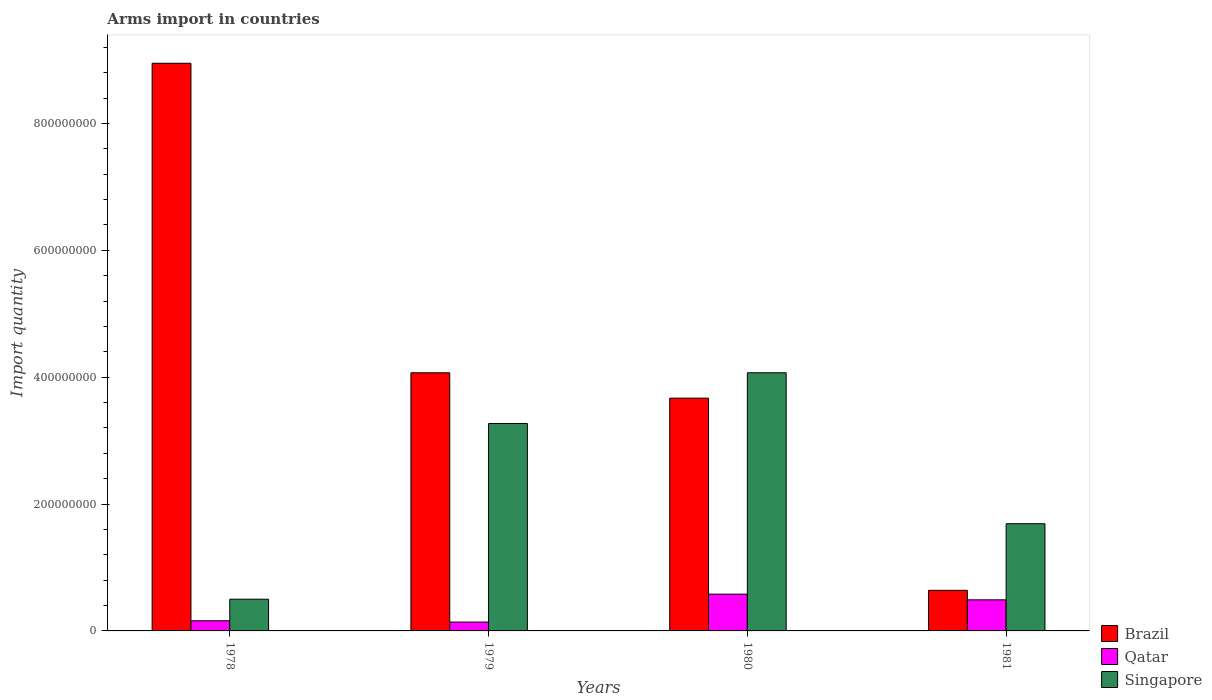How many different coloured bars are there?
Provide a short and direct response. 3. How many bars are there on the 1st tick from the left?
Provide a short and direct response. 3. How many bars are there on the 4th tick from the right?
Provide a short and direct response. 3. What is the label of the 2nd group of bars from the left?
Make the answer very short. 1979. In how many cases, is the number of bars for a given year not equal to the number of legend labels?
Give a very brief answer. 0. What is the total arms import in Qatar in 1978?
Make the answer very short. 1.60e+07. Across all years, what is the maximum total arms import in Singapore?
Provide a short and direct response. 4.07e+08. Across all years, what is the minimum total arms import in Brazil?
Keep it short and to the point. 6.40e+07. In which year was the total arms import in Singapore maximum?
Make the answer very short. 1980. In which year was the total arms import in Brazil minimum?
Offer a very short reply. 1981. What is the total total arms import in Qatar in the graph?
Provide a short and direct response. 1.37e+08. What is the difference between the total arms import in Brazil in 1978 and that in 1980?
Ensure brevity in your answer.  5.28e+08. What is the difference between the total arms import in Qatar in 1978 and the total arms import in Brazil in 1980?
Provide a succinct answer. -3.51e+08. What is the average total arms import in Singapore per year?
Provide a short and direct response. 2.38e+08. In the year 1979, what is the difference between the total arms import in Qatar and total arms import in Singapore?
Your response must be concise. -3.13e+08. What is the ratio of the total arms import in Brazil in 1978 to that in 1981?
Your answer should be very brief. 13.98. Is the total arms import in Qatar in 1978 less than that in 1980?
Offer a terse response. Yes. What is the difference between the highest and the second highest total arms import in Brazil?
Your answer should be compact. 4.88e+08. What is the difference between the highest and the lowest total arms import in Brazil?
Your answer should be very brief. 8.31e+08. What does the 3rd bar from the left in 1978 represents?
Provide a short and direct response. Singapore. What does the 3rd bar from the right in 1980 represents?
Ensure brevity in your answer.  Brazil. Is it the case that in every year, the sum of the total arms import in Brazil and total arms import in Qatar is greater than the total arms import in Singapore?
Keep it short and to the point. No. Are all the bars in the graph horizontal?
Give a very brief answer. No. What is the difference between two consecutive major ticks on the Y-axis?
Offer a very short reply. 2.00e+08. Does the graph contain any zero values?
Your answer should be compact. No. Does the graph contain grids?
Your response must be concise. No. Where does the legend appear in the graph?
Provide a succinct answer. Bottom right. What is the title of the graph?
Make the answer very short. Arms import in countries. What is the label or title of the X-axis?
Your answer should be compact. Years. What is the label or title of the Y-axis?
Provide a succinct answer. Import quantity. What is the Import quantity in Brazil in 1978?
Offer a terse response. 8.95e+08. What is the Import quantity of Qatar in 1978?
Offer a very short reply. 1.60e+07. What is the Import quantity in Singapore in 1978?
Provide a succinct answer. 5.00e+07. What is the Import quantity in Brazil in 1979?
Ensure brevity in your answer.  4.07e+08. What is the Import quantity in Qatar in 1979?
Make the answer very short. 1.40e+07. What is the Import quantity of Singapore in 1979?
Your answer should be very brief. 3.27e+08. What is the Import quantity in Brazil in 1980?
Offer a terse response. 3.67e+08. What is the Import quantity of Qatar in 1980?
Offer a terse response. 5.80e+07. What is the Import quantity of Singapore in 1980?
Ensure brevity in your answer.  4.07e+08. What is the Import quantity in Brazil in 1981?
Your answer should be compact. 6.40e+07. What is the Import quantity in Qatar in 1981?
Your response must be concise. 4.90e+07. What is the Import quantity of Singapore in 1981?
Give a very brief answer. 1.69e+08. Across all years, what is the maximum Import quantity in Brazil?
Ensure brevity in your answer.  8.95e+08. Across all years, what is the maximum Import quantity in Qatar?
Your answer should be very brief. 5.80e+07. Across all years, what is the maximum Import quantity in Singapore?
Provide a succinct answer. 4.07e+08. Across all years, what is the minimum Import quantity of Brazil?
Provide a succinct answer. 6.40e+07. Across all years, what is the minimum Import quantity in Qatar?
Offer a very short reply. 1.40e+07. What is the total Import quantity in Brazil in the graph?
Your answer should be compact. 1.73e+09. What is the total Import quantity in Qatar in the graph?
Your answer should be very brief. 1.37e+08. What is the total Import quantity in Singapore in the graph?
Your response must be concise. 9.53e+08. What is the difference between the Import quantity of Brazil in 1978 and that in 1979?
Your answer should be compact. 4.88e+08. What is the difference between the Import quantity of Singapore in 1978 and that in 1979?
Your answer should be very brief. -2.77e+08. What is the difference between the Import quantity in Brazil in 1978 and that in 1980?
Give a very brief answer. 5.28e+08. What is the difference between the Import quantity of Qatar in 1978 and that in 1980?
Offer a very short reply. -4.20e+07. What is the difference between the Import quantity in Singapore in 1978 and that in 1980?
Make the answer very short. -3.57e+08. What is the difference between the Import quantity of Brazil in 1978 and that in 1981?
Your answer should be compact. 8.31e+08. What is the difference between the Import quantity in Qatar in 1978 and that in 1981?
Offer a very short reply. -3.30e+07. What is the difference between the Import quantity of Singapore in 1978 and that in 1981?
Give a very brief answer. -1.19e+08. What is the difference between the Import quantity in Brazil in 1979 and that in 1980?
Offer a terse response. 4.00e+07. What is the difference between the Import quantity in Qatar in 1979 and that in 1980?
Provide a short and direct response. -4.40e+07. What is the difference between the Import quantity in Singapore in 1979 and that in 1980?
Your answer should be very brief. -8.00e+07. What is the difference between the Import quantity of Brazil in 1979 and that in 1981?
Offer a very short reply. 3.43e+08. What is the difference between the Import quantity of Qatar in 1979 and that in 1981?
Make the answer very short. -3.50e+07. What is the difference between the Import quantity in Singapore in 1979 and that in 1981?
Make the answer very short. 1.58e+08. What is the difference between the Import quantity of Brazil in 1980 and that in 1981?
Your answer should be compact. 3.03e+08. What is the difference between the Import quantity of Qatar in 1980 and that in 1981?
Ensure brevity in your answer.  9.00e+06. What is the difference between the Import quantity in Singapore in 1980 and that in 1981?
Your response must be concise. 2.38e+08. What is the difference between the Import quantity in Brazil in 1978 and the Import quantity in Qatar in 1979?
Your answer should be very brief. 8.81e+08. What is the difference between the Import quantity of Brazil in 1978 and the Import quantity of Singapore in 1979?
Make the answer very short. 5.68e+08. What is the difference between the Import quantity of Qatar in 1978 and the Import quantity of Singapore in 1979?
Ensure brevity in your answer.  -3.11e+08. What is the difference between the Import quantity of Brazil in 1978 and the Import quantity of Qatar in 1980?
Offer a terse response. 8.37e+08. What is the difference between the Import quantity in Brazil in 1978 and the Import quantity in Singapore in 1980?
Your response must be concise. 4.88e+08. What is the difference between the Import quantity in Qatar in 1978 and the Import quantity in Singapore in 1980?
Offer a terse response. -3.91e+08. What is the difference between the Import quantity of Brazil in 1978 and the Import quantity of Qatar in 1981?
Your response must be concise. 8.46e+08. What is the difference between the Import quantity in Brazil in 1978 and the Import quantity in Singapore in 1981?
Keep it short and to the point. 7.26e+08. What is the difference between the Import quantity of Qatar in 1978 and the Import quantity of Singapore in 1981?
Make the answer very short. -1.53e+08. What is the difference between the Import quantity in Brazil in 1979 and the Import quantity in Qatar in 1980?
Provide a succinct answer. 3.49e+08. What is the difference between the Import quantity in Brazil in 1979 and the Import quantity in Singapore in 1980?
Your answer should be very brief. 0. What is the difference between the Import quantity of Qatar in 1979 and the Import quantity of Singapore in 1980?
Your answer should be compact. -3.93e+08. What is the difference between the Import quantity of Brazil in 1979 and the Import quantity of Qatar in 1981?
Provide a succinct answer. 3.58e+08. What is the difference between the Import quantity of Brazil in 1979 and the Import quantity of Singapore in 1981?
Offer a very short reply. 2.38e+08. What is the difference between the Import quantity of Qatar in 1979 and the Import quantity of Singapore in 1981?
Provide a succinct answer. -1.55e+08. What is the difference between the Import quantity in Brazil in 1980 and the Import quantity in Qatar in 1981?
Offer a very short reply. 3.18e+08. What is the difference between the Import quantity in Brazil in 1980 and the Import quantity in Singapore in 1981?
Your answer should be compact. 1.98e+08. What is the difference between the Import quantity of Qatar in 1980 and the Import quantity of Singapore in 1981?
Keep it short and to the point. -1.11e+08. What is the average Import quantity in Brazil per year?
Offer a very short reply. 4.33e+08. What is the average Import quantity of Qatar per year?
Your response must be concise. 3.42e+07. What is the average Import quantity of Singapore per year?
Offer a very short reply. 2.38e+08. In the year 1978, what is the difference between the Import quantity in Brazil and Import quantity in Qatar?
Make the answer very short. 8.79e+08. In the year 1978, what is the difference between the Import quantity of Brazil and Import quantity of Singapore?
Provide a succinct answer. 8.45e+08. In the year 1978, what is the difference between the Import quantity of Qatar and Import quantity of Singapore?
Provide a succinct answer. -3.40e+07. In the year 1979, what is the difference between the Import quantity in Brazil and Import quantity in Qatar?
Ensure brevity in your answer.  3.93e+08. In the year 1979, what is the difference between the Import quantity of Brazil and Import quantity of Singapore?
Offer a terse response. 8.00e+07. In the year 1979, what is the difference between the Import quantity in Qatar and Import quantity in Singapore?
Give a very brief answer. -3.13e+08. In the year 1980, what is the difference between the Import quantity in Brazil and Import quantity in Qatar?
Provide a succinct answer. 3.09e+08. In the year 1980, what is the difference between the Import quantity of Brazil and Import quantity of Singapore?
Ensure brevity in your answer.  -4.00e+07. In the year 1980, what is the difference between the Import quantity in Qatar and Import quantity in Singapore?
Keep it short and to the point. -3.49e+08. In the year 1981, what is the difference between the Import quantity in Brazil and Import quantity in Qatar?
Offer a very short reply. 1.50e+07. In the year 1981, what is the difference between the Import quantity in Brazil and Import quantity in Singapore?
Provide a succinct answer. -1.05e+08. In the year 1981, what is the difference between the Import quantity of Qatar and Import quantity of Singapore?
Your answer should be very brief. -1.20e+08. What is the ratio of the Import quantity in Brazil in 1978 to that in 1979?
Your answer should be compact. 2.2. What is the ratio of the Import quantity of Singapore in 1978 to that in 1979?
Give a very brief answer. 0.15. What is the ratio of the Import quantity in Brazil in 1978 to that in 1980?
Ensure brevity in your answer.  2.44. What is the ratio of the Import quantity of Qatar in 1978 to that in 1980?
Ensure brevity in your answer.  0.28. What is the ratio of the Import quantity of Singapore in 1978 to that in 1980?
Offer a very short reply. 0.12. What is the ratio of the Import quantity in Brazil in 1978 to that in 1981?
Offer a very short reply. 13.98. What is the ratio of the Import quantity in Qatar in 1978 to that in 1981?
Keep it short and to the point. 0.33. What is the ratio of the Import quantity in Singapore in 1978 to that in 1981?
Make the answer very short. 0.3. What is the ratio of the Import quantity of Brazil in 1979 to that in 1980?
Your response must be concise. 1.11. What is the ratio of the Import quantity in Qatar in 1979 to that in 1980?
Make the answer very short. 0.24. What is the ratio of the Import quantity of Singapore in 1979 to that in 1980?
Your answer should be compact. 0.8. What is the ratio of the Import quantity of Brazil in 1979 to that in 1981?
Provide a succinct answer. 6.36. What is the ratio of the Import quantity in Qatar in 1979 to that in 1981?
Make the answer very short. 0.29. What is the ratio of the Import quantity of Singapore in 1979 to that in 1981?
Give a very brief answer. 1.93. What is the ratio of the Import quantity in Brazil in 1980 to that in 1981?
Provide a short and direct response. 5.73. What is the ratio of the Import quantity of Qatar in 1980 to that in 1981?
Provide a short and direct response. 1.18. What is the ratio of the Import quantity of Singapore in 1980 to that in 1981?
Ensure brevity in your answer.  2.41. What is the difference between the highest and the second highest Import quantity of Brazil?
Your answer should be very brief. 4.88e+08. What is the difference between the highest and the second highest Import quantity of Qatar?
Ensure brevity in your answer.  9.00e+06. What is the difference between the highest and the second highest Import quantity in Singapore?
Your answer should be very brief. 8.00e+07. What is the difference between the highest and the lowest Import quantity of Brazil?
Make the answer very short. 8.31e+08. What is the difference between the highest and the lowest Import quantity in Qatar?
Give a very brief answer. 4.40e+07. What is the difference between the highest and the lowest Import quantity in Singapore?
Offer a terse response. 3.57e+08. 